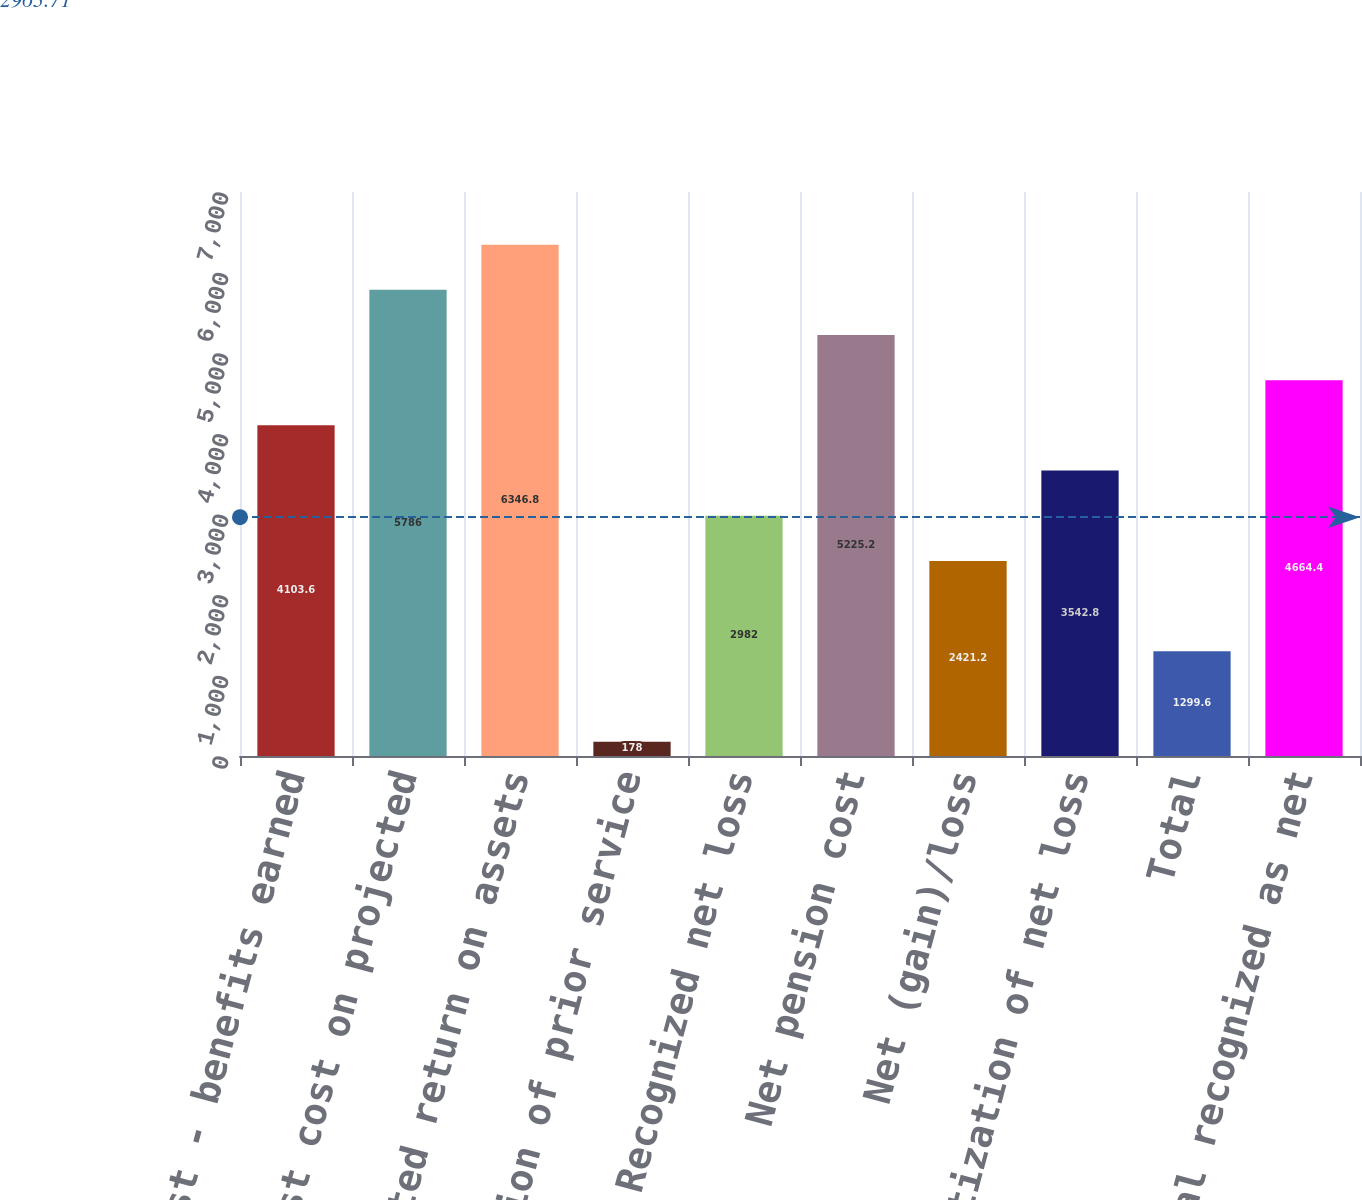Convert chart to OTSL. <chart><loc_0><loc_0><loc_500><loc_500><bar_chart><fcel>Service cost - benefits earned<fcel>Interest cost on projected<fcel>Expected return on assets<fcel>Amortization of prior service<fcel>Recognized net loss<fcel>Net pension cost<fcel>Net (gain)/loss<fcel>Amortization of net loss<fcel>Total<fcel>Total recognized as net<nl><fcel>4103.6<fcel>5786<fcel>6346.8<fcel>178<fcel>2982<fcel>5225.2<fcel>2421.2<fcel>3542.8<fcel>1299.6<fcel>4664.4<nl></chart> 